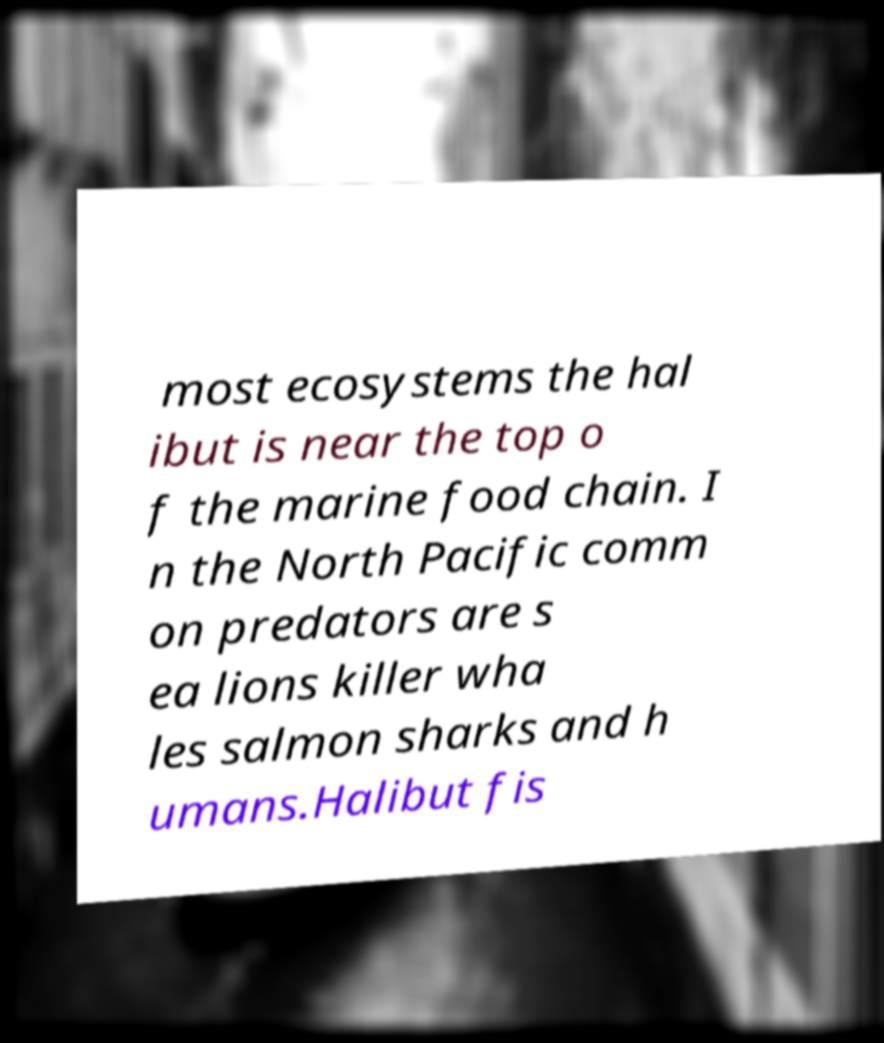What messages or text are displayed in this image? I need them in a readable, typed format. most ecosystems the hal ibut is near the top o f the marine food chain. I n the North Pacific comm on predators are s ea lions killer wha les salmon sharks and h umans.Halibut fis 